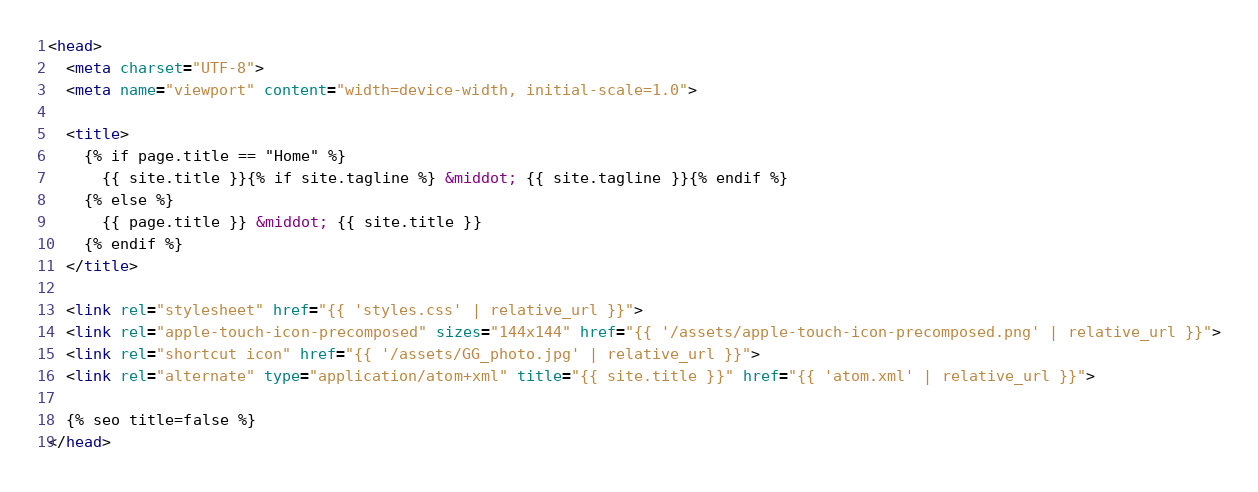Convert code to text. <code><loc_0><loc_0><loc_500><loc_500><_HTML_><head>
  <meta charset="UTF-8">
  <meta name="viewport" content="width=device-width, initial-scale=1.0">

  <title>
    {% if page.title == "Home" %}
      {{ site.title }}{% if site.tagline %} &middot; {{ site.tagline }}{% endif %}
    {% else %}
      {{ page.title }} &middot; {{ site.title }}
    {% endif %}
  </title>

  <link rel="stylesheet" href="{{ 'styles.css' | relative_url }}">
  <link rel="apple-touch-icon-precomposed" sizes="144x144" href="{{ '/assets/apple-touch-icon-precomposed.png' | relative_url }}">
  <link rel="shortcut icon" href="{{ '/assets/GG_photo.jpg' | relative_url }}">
  <link rel="alternate" type="application/atom+xml" title="{{ site.title }}" href="{{ 'atom.xml' | relative_url }}">

  {% seo title=false %}
</head>
</code> 